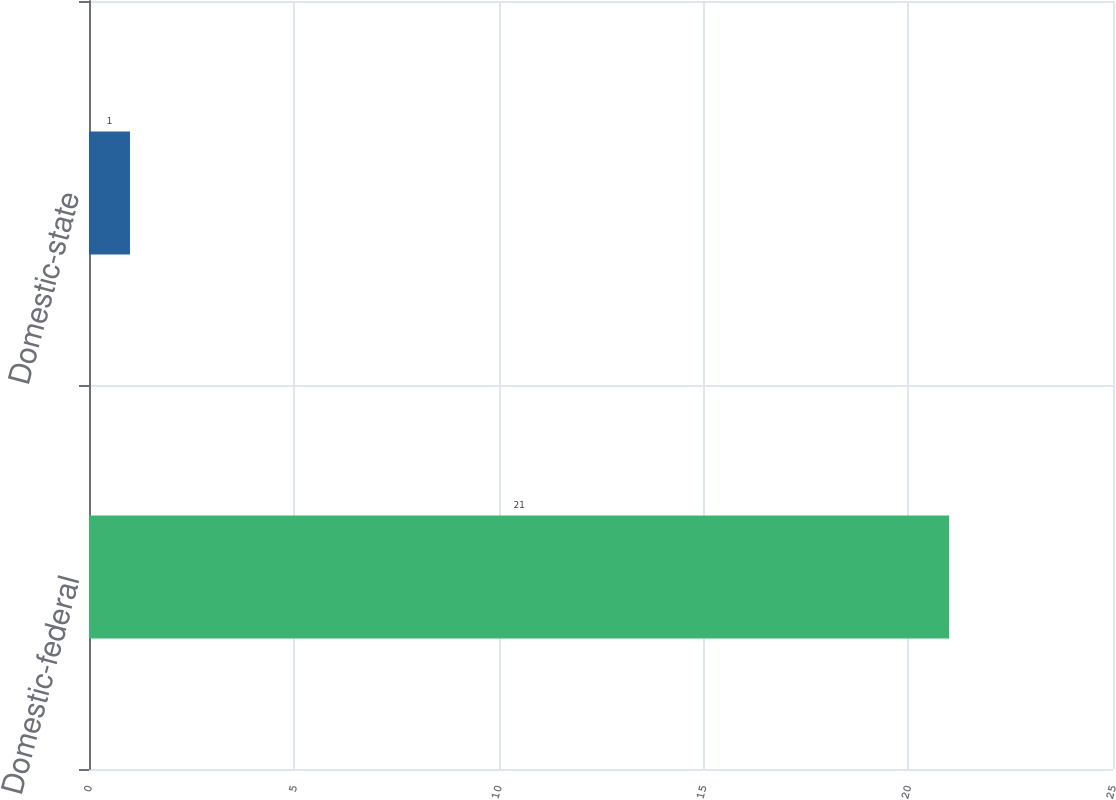Convert chart to OTSL. <chart><loc_0><loc_0><loc_500><loc_500><bar_chart><fcel>Domestic-federal<fcel>Domestic-state<nl><fcel>21<fcel>1<nl></chart> 